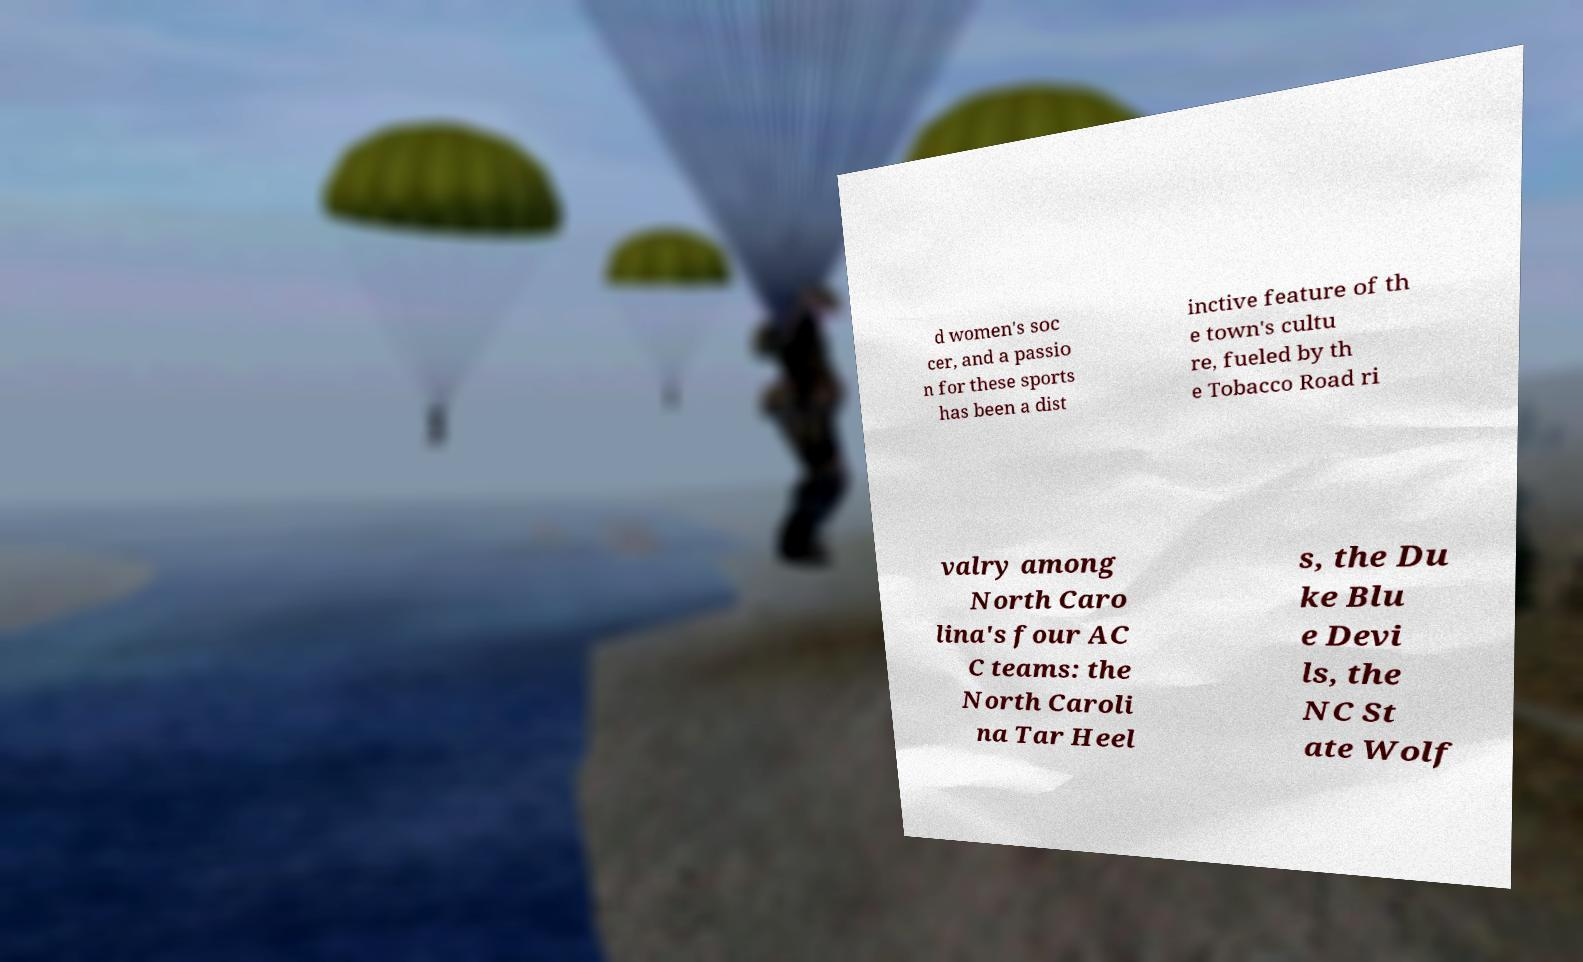Could you extract and type out the text from this image? d women's soc cer, and a passio n for these sports has been a dist inctive feature of th e town's cultu re, fueled by th e Tobacco Road ri valry among North Caro lina's four AC C teams: the North Caroli na Tar Heel s, the Du ke Blu e Devi ls, the NC St ate Wolf 